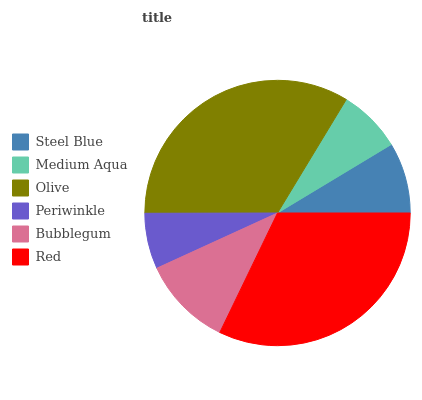Is Periwinkle the minimum?
Answer yes or no. Yes. Is Olive the maximum?
Answer yes or no. Yes. Is Medium Aqua the minimum?
Answer yes or no. No. Is Medium Aqua the maximum?
Answer yes or no. No. Is Steel Blue greater than Medium Aqua?
Answer yes or no. Yes. Is Medium Aqua less than Steel Blue?
Answer yes or no. Yes. Is Medium Aqua greater than Steel Blue?
Answer yes or no. No. Is Steel Blue less than Medium Aqua?
Answer yes or no. No. Is Bubblegum the high median?
Answer yes or no. Yes. Is Steel Blue the low median?
Answer yes or no. Yes. Is Olive the high median?
Answer yes or no. No. Is Medium Aqua the low median?
Answer yes or no. No. 